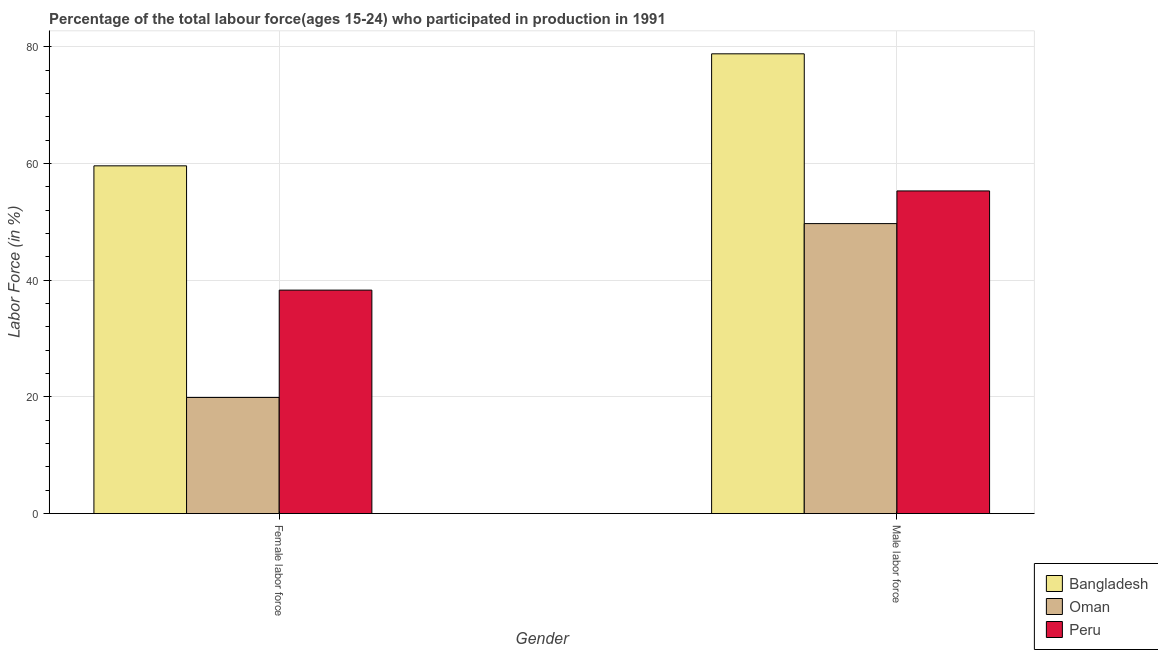How many different coloured bars are there?
Offer a terse response. 3. How many groups of bars are there?
Provide a short and direct response. 2. How many bars are there on the 2nd tick from the right?
Your response must be concise. 3. What is the label of the 1st group of bars from the left?
Offer a very short reply. Female labor force. What is the percentage of female labor force in Peru?
Keep it short and to the point. 38.3. Across all countries, what is the maximum percentage of male labour force?
Your answer should be very brief. 78.8. Across all countries, what is the minimum percentage of male labour force?
Give a very brief answer. 49.7. In which country was the percentage of male labour force minimum?
Your answer should be very brief. Oman. What is the total percentage of female labor force in the graph?
Your answer should be very brief. 117.8. What is the difference between the percentage of female labor force in Peru and that in Bangladesh?
Provide a succinct answer. -21.3. What is the difference between the percentage of female labor force in Peru and the percentage of male labour force in Oman?
Make the answer very short. -11.4. What is the average percentage of female labor force per country?
Ensure brevity in your answer.  39.27. What is the difference between the percentage of female labor force and percentage of male labour force in Bangladesh?
Provide a short and direct response. -19.2. In how many countries, is the percentage of male labour force greater than 56 %?
Make the answer very short. 1. What is the ratio of the percentage of male labour force in Oman to that in Bangladesh?
Give a very brief answer. 0.63. In how many countries, is the percentage of female labor force greater than the average percentage of female labor force taken over all countries?
Provide a short and direct response. 1. How many bars are there?
Provide a succinct answer. 6. Are all the bars in the graph horizontal?
Provide a succinct answer. No. Are the values on the major ticks of Y-axis written in scientific E-notation?
Offer a terse response. No. Does the graph contain grids?
Provide a short and direct response. Yes. Where does the legend appear in the graph?
Provide a short and direct response. Bottom right. How many legend labels are there?
Your answer should be very brief. 3. How are the legend labels stacked?
Offer a very short reply. Vertical. What is the title of the graph?
Your answer should be compact. Percentage of the total labour force(ages 15-24) who participated in production in 1991. Does "Korea (Republic)" appear as one of the legend labels in the graph?
Make the answer very short. No. What is the label or title of the X-axis?
Offer a terse response. Gender. What is the Labor Force (in %) of Bangladesh in Female labor force?
Provide a short and direct response. 59.6. What is the Labor Force (in %) of Oman in Female labor force?
Offer a very short reply. 19.9. What is the Labor Force (in %) of Peru in Female labor force?
Provide a succinct answer. 38.3. What is the Labor Force (in %) in Bangladesh in Male labor force?
Keep it short and to the point. 78.8. What is the Labor Force (in %) of Oman in Male labor force?
Provide a short and direct response. 49.7. What is the Labor Force (in %) in Peru in Male labor force?
Your answer should be compact. 55.3. Across all Gender, what is the maximum Labor Force (in %) in Bangladesh?
Offer a very short reply. 78.8. Across all Gender, what is the maximum Labor Force (in %) in Oman?
Ensure brevity in your answer.  49.7. Across all Gender, what is the maximum Labor Force (in %) in Peru?
Provide a short and direct response. 55.3. Across all Gender, what is the minimum Labor Force (in %) of Bangladesh?
Keep it short and to the point. 59.6. Across all Gender, what is the minimum Labor Force (in %) of Oman?
Make the answer very short. 19.9. Across all Gender, what is the minimum Labor Force (in %) in Peru?
Ensure brevity in your answer.  38.3. What is the total Labor Force (in %) in Bangladesh in the graph?
Provide a short and direct response. 138.4. What is the total Labor Force (in %) in Oman in the graph?
Your answer should be compact. 69.6. What is the total Labor Force (in %) of Peru in the graph?
Offer a very short reply. 93.6. What is the difference between the Labor Force (in %) of Bangladesh in Female labor force and that in Male labor force?
Ensure brevity in your answer.  -19.2. What is the difference between the Labor Force (in %) of Oman in Female labor force and that in Male labor force?
Offer a terse response. -29.8. What is the difference between the Labor Force (in %) in Peru in Female labor force and that in Male labor force?
Your answer should be very brief. -17. What is the difference between the Labor Force (in %) of Bangladesh in Female labor force and the Labor Force (in %) of Oman in Male labor force?
Keep it short and to the point. 9.9. What is the difference between the Labor Force (in %) of Oman in Female labor force and the Labor Force (in %) of Peru in Male labor force?
Ensure brevity in your answer.  -35.4. What is the average Labor Force (in %) in Bangladesh per Gender?
Offer a very short reply. 69.2. What is the average Labor Force (in %) of Oman per Gender?
Make the answer very short. 34.8. What is the average Labor Force (in %) in Peru per Gender?
Give a very brief answer. 46.8. What is the difference between the Labor Force (in %) in Bangladesh and Labor Force (in %) in Oman in Female labor force?
Offer a very short reply. 39.7. What is the difference between the Labor Force (in %) of Bangladesh and Labor Force (in %) of Peru in Female labor force?
Ensure brevity in your answer.  21.3. What is the difference between the Labor Force (in %) of Oman and Labor Force (in %) of Peru in Female labor force?
Ensure brevity in your answer.  -18.4. What is the difference between the Labor Force (in %) of Bangladesh and Labor Force (in %) of Oman in Male labor force?
Provide a short and direct response. 29.1. What is the difference between the Labor Force (in %) in Bangladesh and Labor Force (in %) in Peru in Male labor force?
Provide a short and direct response. 23.5. What is the difference between the Labor Force (in %) in Oman and Labor Force (in %) in Peru in Male labor force?
Offer a terse response. -5.6. What is the ratio of the Labor Force (in %) of Bangladesh in Female labor force to that in Male labor force?
Your answer should be compact. 0.76. What is the ratio of the Labor Force (in %) of Oman in Female labor force to that in Male labor force?
Your answer should be very brief. 0.4. What is the ratio of the Labor Force (in %) in Peru in Female labor force to that in Male labor force?
Provide a short and direct response. 0.69. What is the difference between the highest and the second highest Labor Force (in %) of Oman?
Offer a terse response. 29.8. What is the difference between the highest and the second highest Labor Force (in %) of Peru?
Offer a very short reply. 17. What is the difference between the highest and the lowest Labor Force (in %) in Bangladesh?
Make the answer very short. 19.2. What is the difference between the highest and the lowest Labor Force (in %) in Oman?
Your answer should be compact. 29.8. What is the difference between the highest and the lowest Labor Force (in %) in Peru?
Provide a short and direct response. 17. 